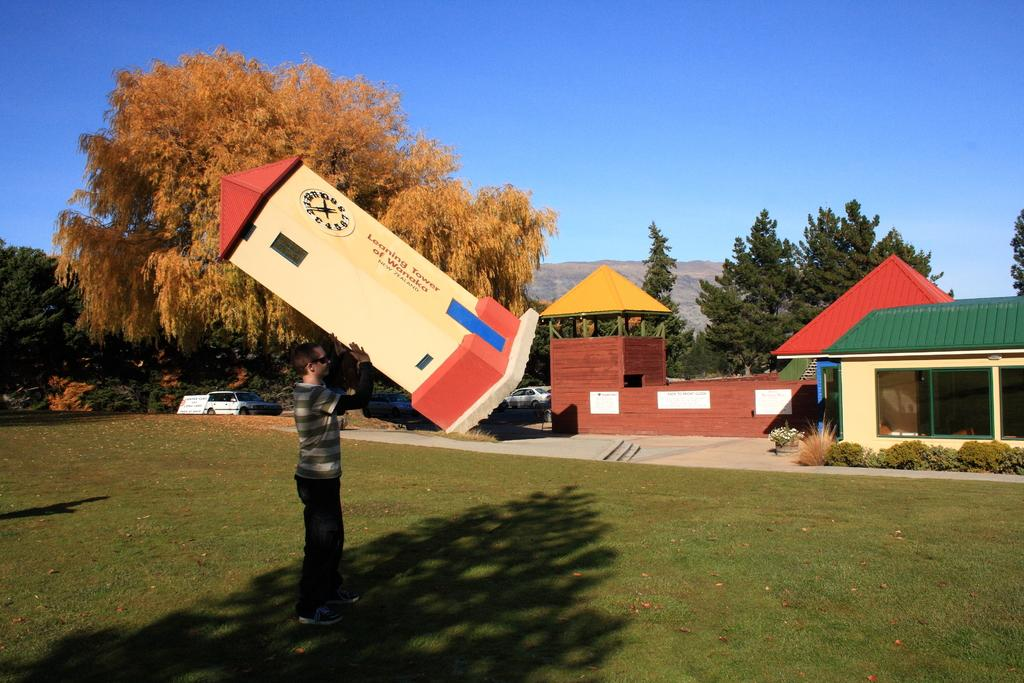What is the main subject of the image? There is a person in the image. What is the person holding in the image? The person is holding a tower-like object. What feature does the tower-like object have? The tower-like object has a clock on it. What type of structures can be seen in the image? There are houses in the image. What type of vegetation can be seen in the image? There are trees in the image. What mode of transportation can be seen in the image? There is a car in the image. What type of cable is being used to connect the mass to the tower in the image? There is no cable or mass present in the image; the person is holding a tower-like object with a clock on it. 